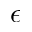Convert formula to latex. <formula><loc_0><loc_0><loc_500><loc_500>\epsilon</formula> 